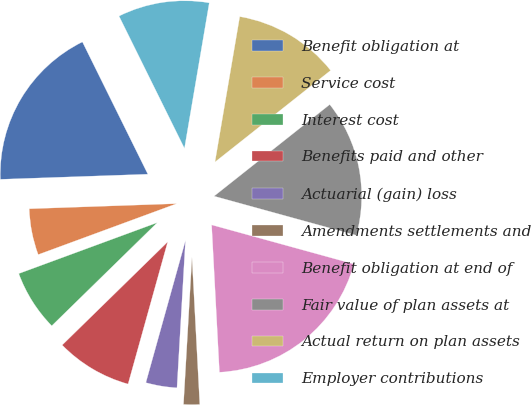Convert chart to OTSL. <chart><loc_0><loc_0><loc_500><loc_500><pie_chart><fcel>Benefit obligation at<fcel>Service cost<fcel>Interest cost<fcel>Benefits paid and other<fcel>Actuarial (gain) loss<fcel>Amendments settlements and<fcel>Benefit obligation at end of<fcel>Fair value of plan assets at<fcel>Actual return on plan assets<fcel>Employer contributions<nl><fcel>18.24%<fcel>5.06%<fcel>6.71%<fcel>8.35%<fcel>3.41%<fcel>1.76%<fcel>19.88%<fcel>14.94%<fcel>11.65%<fcel>10.0%<nl></chart> 